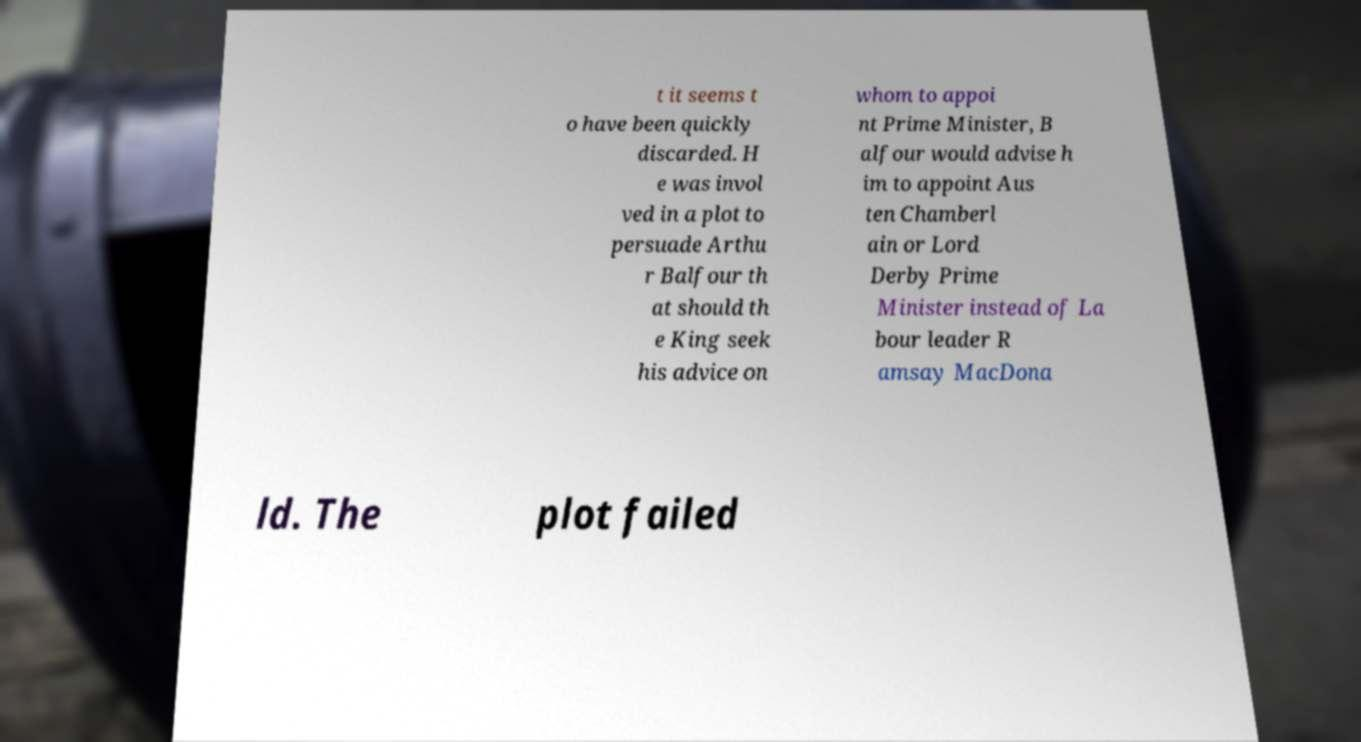Please read and relay the text visible in this image. What does it say? t it seems t o have been quickly discarded. H e was invol ved in a plot to persuade Arthu r Balfour th at should th e King seek his advice on whom to appoi nt Prime Minister, B alfour would advise h im to appoint Aus ten Chamberl ain or Lord Derby Prime Minister instead of La bour leader R amsay MacDona ld. The plot failed 